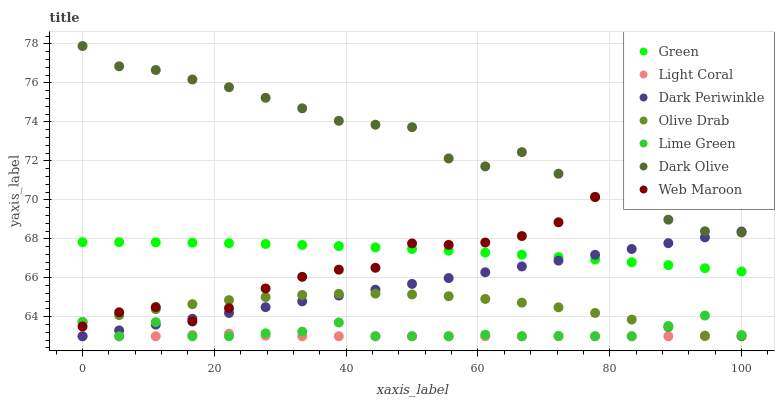Does Light Coral have the minimum area under the curve?
Answer yes or no. Yes. Does Dark Olive have the maximum area under the curve?
Answer yes or no. Yes. Does Web Maroon have the minimum area under the curve?
Answer yes or no. No. Does Web Maroon have the maximum area under the curve?
Answer yes or no. No. Is Dark Periwinkle the smoothest?
Answer yes or no. Yes. Is Web Maroon the roughest?
Answer yes or no. Yes. Is Light Coral the smoothest?
Answer yes or no. No. Is Light Coral the roughest?
Answer yes or no. No. Does Light Coral have the lowest value?
Answer yes or no. Yes. Does Web Maroon have the lowest value?
Answer yes or no. No. Does Dark Olive have the highest value?
Answer yes or no. Yes. Does Web Maroon have the highest value?
Answer yes or no. No. Is Olive Drab less than Dark Olive?
Answer yes or no. Yes. Is Dark Olive greater than Olive Drab?
Answer yes or no. Yes. Does Dark Olive intersect Web Maroon?
Answer yes or no. Yes. Is Dark Olive less than Web Maroon?
Answer yes or no. No. Is Dark Olive greater than Web Maroon?
Answer yes or no. No. Does Olive Drab intersect Dark Olive?
Answer yes or no. No. 